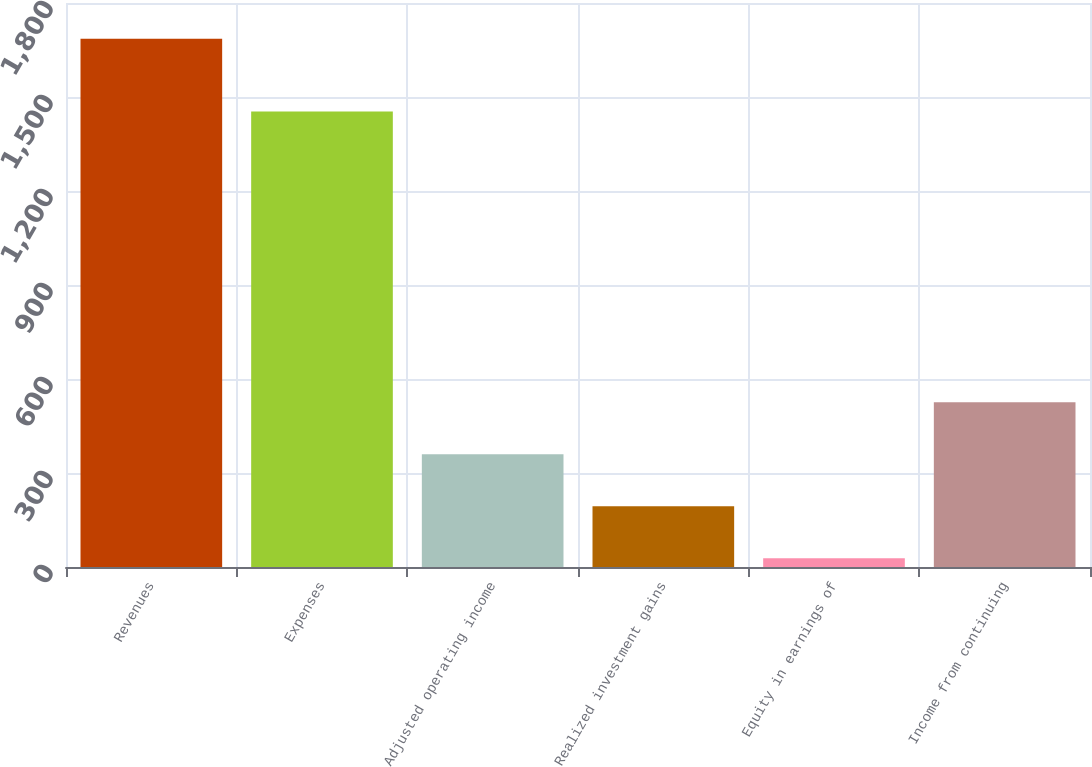Convert chart to OTSL. <chart><loc_0><loc_0><loc_500><loc_500><bar_chart><fcel>Revenues<fcel>Expenses<fcel>Adjusted operating income<fcel>Realized investment gains<fcel>Equity in earnings of<fcel>Income from continuing<nl><fcel>1686<fcel>1454<fcel>359.6<fcel>193.8<fcel>28<fcel>525.4<nl></chart> 